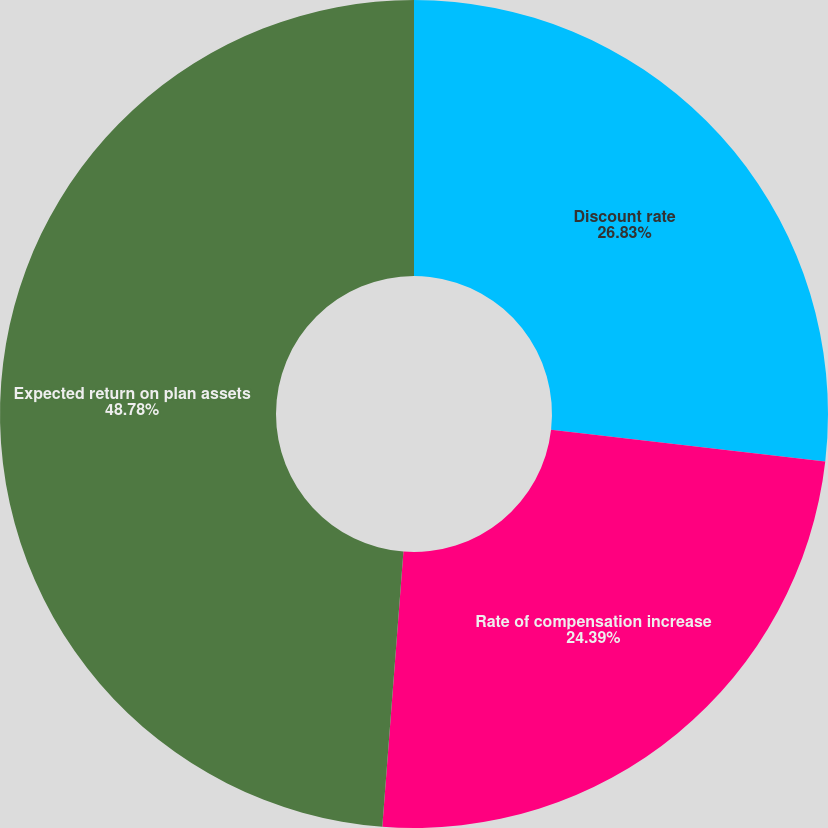Convert chart to OTSL. <chart><loc_0><loc_0><loc_500><loc_500><pie_chart><fcel>Discount rate<fcel>Rate of compensation increase<fcel>Expected return on plan assets<nl><fcel>26.83%<fcel>24.39%<fcel>48.78%<nl></chart> 